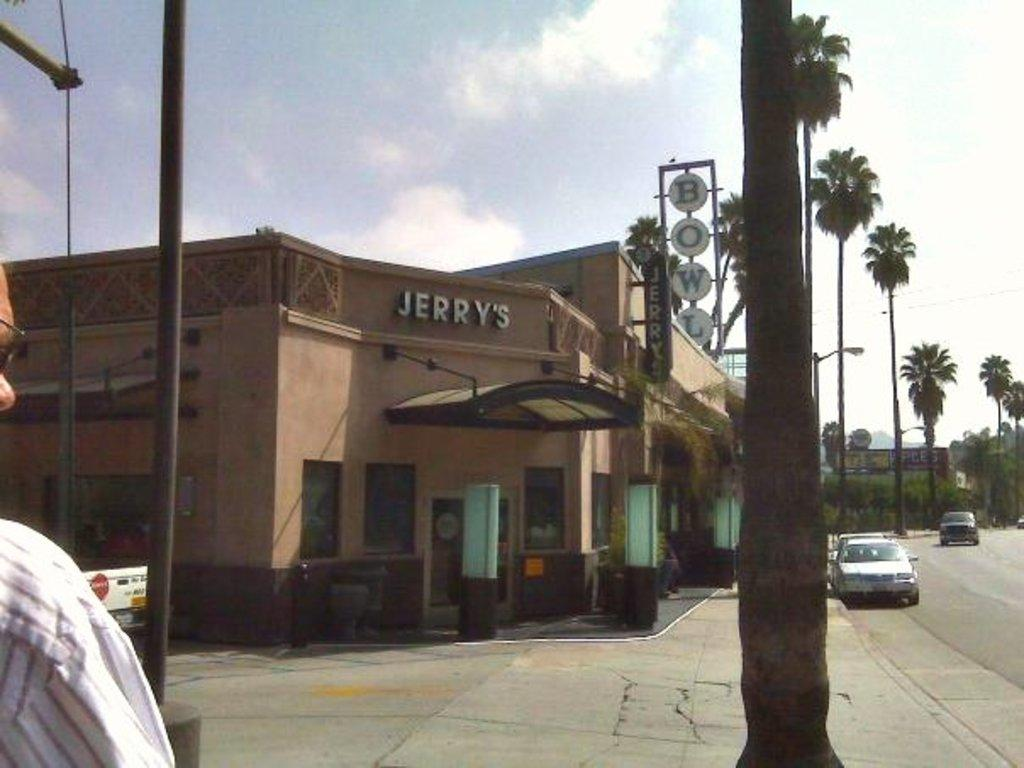What type of structure can be seen in the image? There is a building in the image. What natural elements are present in the image? There are trees in the image. What man-made objects can be seen in the image? Vehicles, poles, lights, and boards are visible in the image. Are there any people in the image? Yes, there is a person in the image. What can be seen in the background of the image? The sky with clouds is visible in the background of the image. What type of toothbrush is the person using in the image? There is no toothbrush present in the image. What kind of support can be seen holding up the building in the image? The image does not show any specific support holding up the building; it only shows the building itself. 